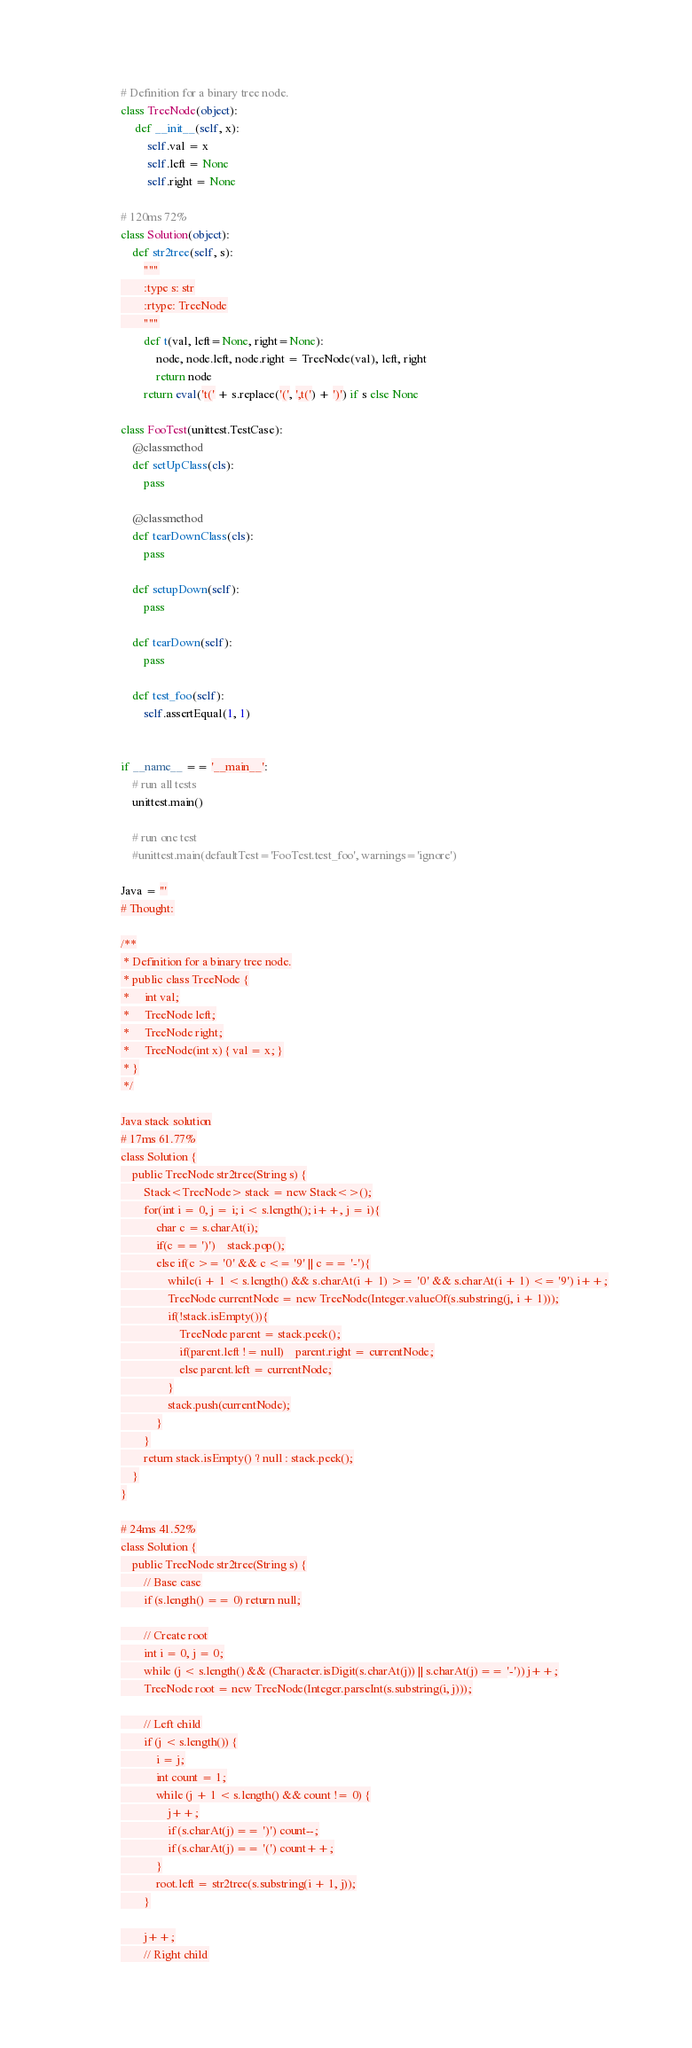<code> <loc_0><loc_0><loc_500><loc_500><_Python_># Definition for a binary tree node.
class TreeNode(object):
     def __init__(self, x):
         self.val = x
         self.left = None
         self.right = None

# 120ms 72%
class Solution(object):
    def str2tree(self, s):
        """
        :type s: str
        :rtype: TreeNode
        """
        def t(val, left=None, right=None):
            node, node.left, node.right = TreeNode(val), left, right
            return node
        return eval('t(' + s.replace('(', ',t(') + ')') if s else None

class FooTest(unittest.TestCase):
    @classmethod
    def setUpClass(cls):
        pass

    @classmethod
    def tearDownClass(cls):
        pass

    def setupDown(self):
        pass

    def tearDown(self):
        pass

    def test_foo(self):
        self.assertEqual(1, 1)


if __name__ == '__main__':
    # run all tests
    unittest.main()

    # run one test
    #unittest.main(defaultTest='FooTest.test_foo', warnings='ignore')

Java = '''
# Thought:

/**
 * Definition for a binary tree node.
 * public class TreeNode {
 *     int val;
 *     TreeNode left;
 *     TreeNode right;
 *     TreeNode(int x) { val = x; }
 * }
 */

Java stack solution
# 17ms 61.77%
class Solution {
    public TreeNode str2tree(String s) {
        Stack<TreeNode> stack = new Stack<>();
        for(int i = 0, j = i; i < s.length(); i++, j = i){
            char c = s.charAt(i);
            if(c == ')')    stack.pop();
            else if(c >= '0' && c <= '9' || c == '-'){
                while(i + 1 < s.length() && s.charAt(i + 1) >= '0' && s.charAt(i + 1) <= '9') i++;
                TreeNode currentNode = new TreeNode(Integer.valueOf(s.substring(j, i + 1)));
                if(!stack.isEmpty()){
                    TreeNode parent = stack.peek();
                    if(parent.left != null)    parent.right = currentNode;
                    else parent.left = currentNode;
                }
                stack.push(currentNode);
            }
        }
        return stack.isEmpty() ? null : stack.peek();
    }
}

# 24ms 41.52%
class Solution {
    public TreeNode str2tree(String s) {
        // Base case
        if (s.length() == 0) return null;

        // Create root
        int i = 0, j = 0;
        while (j < s.length() && (Character.isDigit(s.charAt(j)) || s.charAt(j) == '-')) j++;
        TreeNode root = new TreeNode(Integer.parseInt(s.substring(i, j)));

        // Left child
        if (j < s.length()) {
            i = j;
            int count = 1;
            while (j + 1 < s.length() && count != 0) {
                j++;
                if (s.charAt(j) == ')') count--;
                if (s.charAt(j) == '(') count++;
            }
            root.left = str2tree(s.substring(i + 1, j));
        }

        j++;
        // Right child</code> 